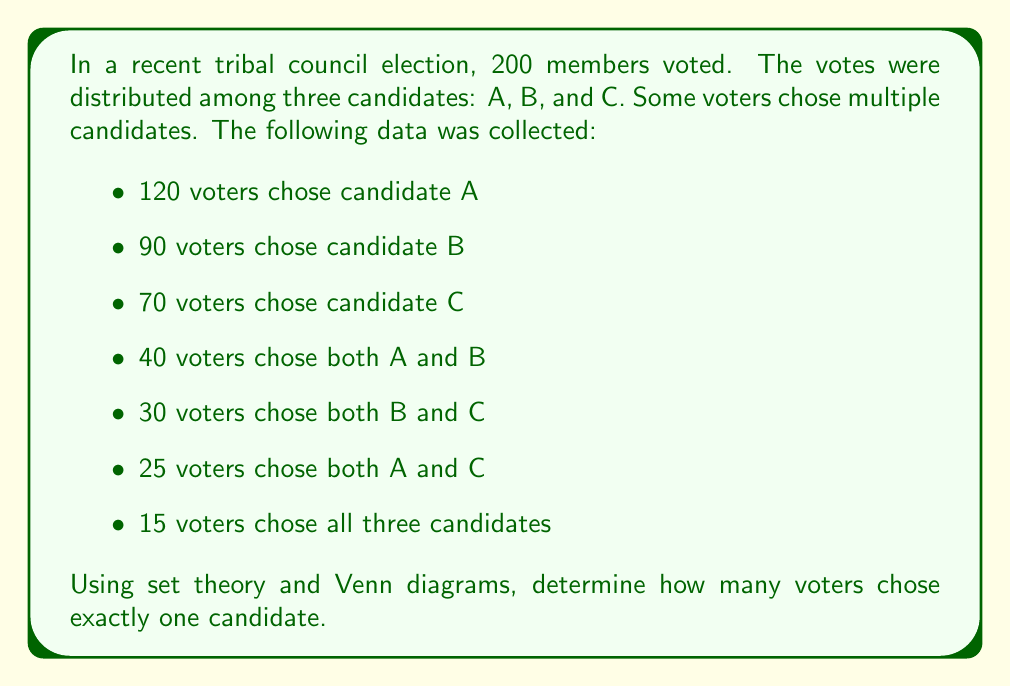Can you answer this question? Let's approach this step-by-step using set theory and a Venn diagram:

1) First, let's draw a Venn diagram with three sets: A, B, and C.

[asy]
unitsize(1cm);

pair A = (-1,0), B = (1,0), C = (0,1.732);
real r = 1.5;

path cA = circle(A, r);
path cB = circle(B, r);
path cC = circle(C, r);

fill(cA, rgb(1,0.7,0.7));
fill(cB, rgb(0.7,1,0.7));
fill(cC, rgb(0.7,0.7,1));

draw(cA);
draw(cB);
draw(cC);

label("A", A, SW);
label("B", B, SE);
label("C", C, N);

label("15", (0,0.577));
label("25", (-0.5,1));
label("30", (0.5,1));
label("40", (0,0));
[/asy]

2) We're given the number of voters who chose all three candidates: 15. Let's fill this in the center of the diagram.

3) Now, let's calculate the number of voters who chose exactly two candidates:
   - A and B only: $40 - 15 = 25$
   - B and C only: $30 - 15 = 15$
   - A and C only: $25 - 15 = 10$

4) Next, we can calculate the number of voters who chose exactly one candidate:
   - A only: $120 - (25 + 10 + 15) = 70$
   - B only: $90 - (25 + 15 + 15) = 35$
   - C only: $70 - (10 + 15 + 15) = 30$

5) To find the total number of voters who chose exactly one candidate, we sum these values:

   $70 + 35 + 30 = 135$

6) We can verify our result using the inclusion-exclusion principle:
   
   $|A \cup B \cup C| = |A| + |B| + |C| - |A \cap B| - |B \cap C| - |A \cap C| + |A \cap B \cap C|$
   
   $200 = 120 + 90 + 70 - 40 - 30 - 25 + 15$
   
   $200 = 200$

This confirms our calculations are correct.
Answer: 135 voters chose exactly one candidate. 